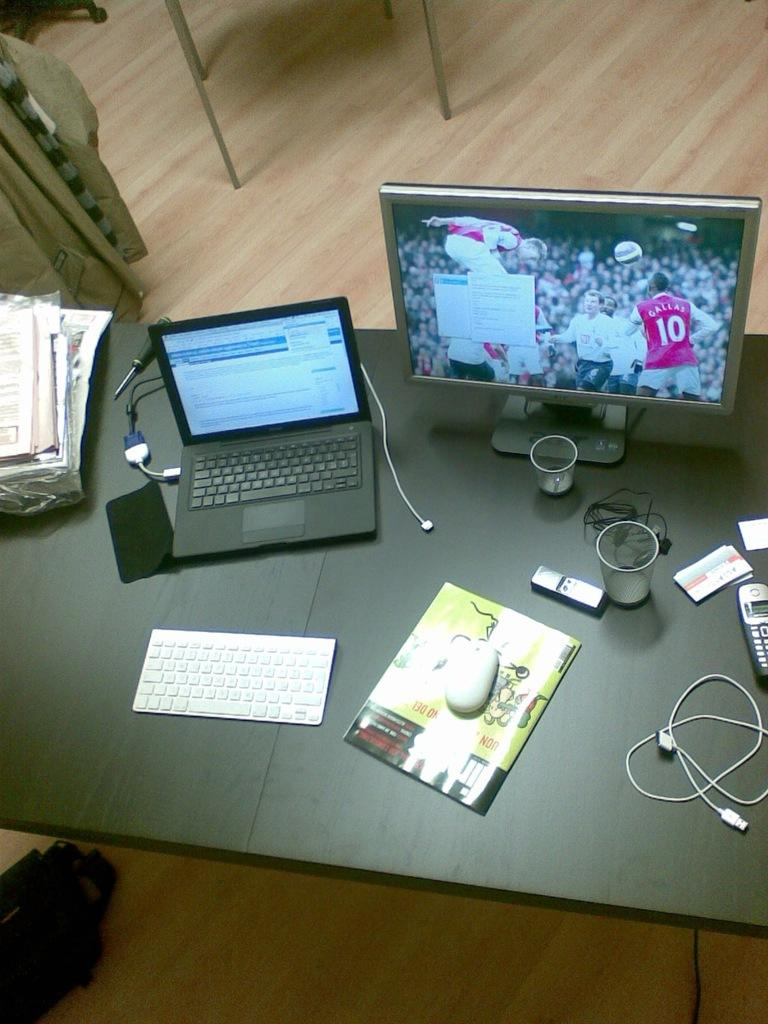What piece of furniture is present in the image? There is a table in the image. What is placed on the table? There are many objects placed on the table. How many chairs are in the image? There are two chairs in the image. Where are the few objects located in the image? The few objects are at the left side of the image. What type of gun is being used by the actor in the image? There is no actor or gun present in the image; it only features a table with objects and chairs. 